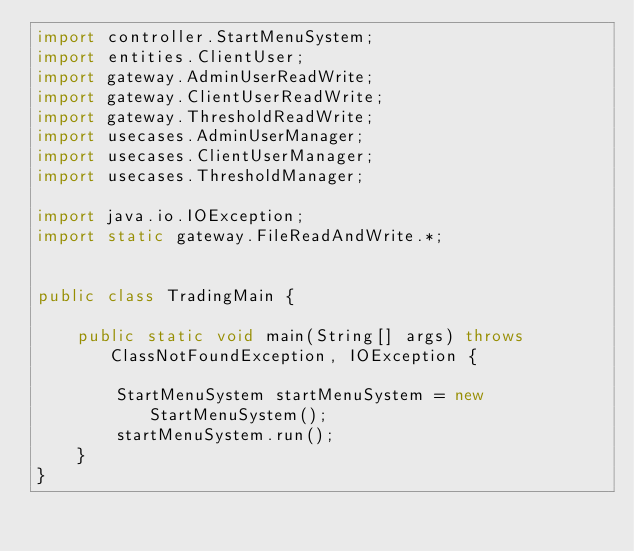<code> <loc_0><loc_0><loc_500><loc_500><_Java_>import controller.StartMenuSystem;
import entities.ClientUser;
import gateway.AdminUserReadWrite;
import gateway.ClientUserReadWrite;
import gateway.ThresholdReadWrite;
import usecases.AdminUserManager;
import usecases.ClientUserManager;
import usecases.ThresholdManager;

import java.io.IOException;
import static gateway.FileReadAndWrite.*;


public class TradingMain {

    public static void main(String[] args) throws ClassNotFoundException, IOException {

        StartMenuSystem startMenuSystem = new StartMenuSystem();
        startMenuSystem.run();
    }
}
</code> 